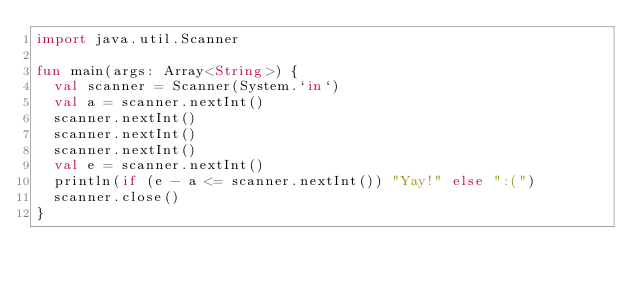<code> <loc_0><loc_0><loc_500><loc_500><_Kotlin_>import java.util.Scanner

fun main(args: Array<String>) {
  val scanner = Scanner(System.`in`)
  val a = scanner.nextInt()
  scanner.nextInt()
  scanner.nextInt()
  scanner.nextInt()
  val e = scanner.nextInt()
  println(if (e - a <= scanner.nextInt()) "Yay!" else ":(")
  scanner.close()
}</code> 